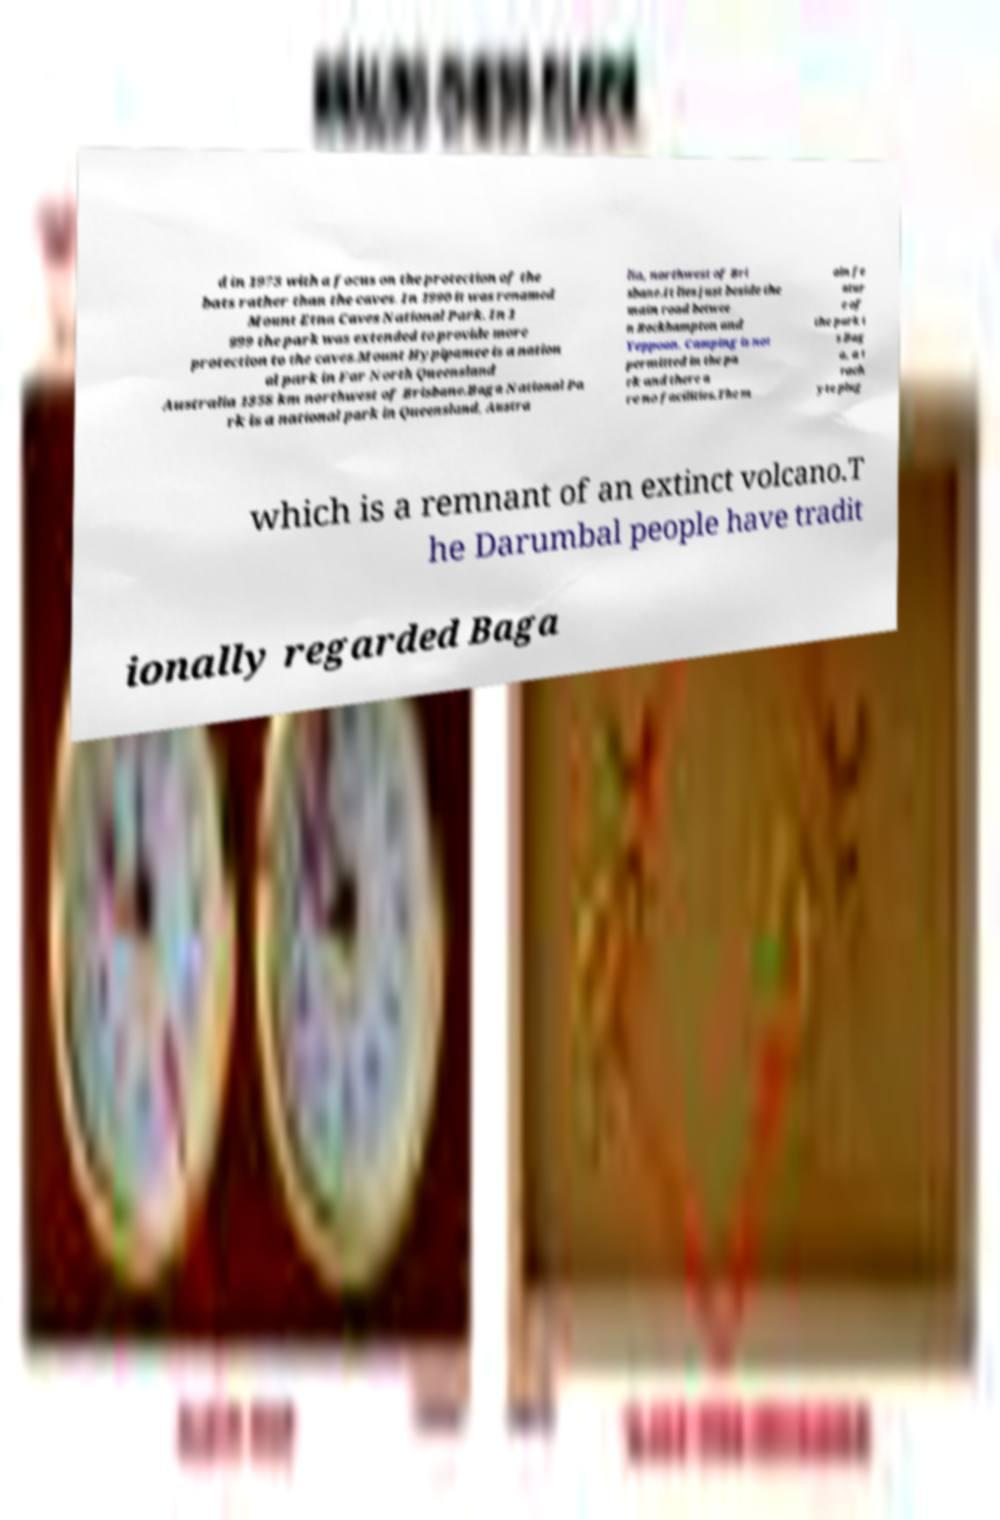Please read and relay the text visible in this image. What does it say? d in 1973 with a focus on the protection of the bats rather than the caves. In 1990 it was renamed Mount Etna Caves National Park. In 1 999 the park was extended to provide more protection to the caves.Mount Hypipamee is a nation al park in Far North Queensland Australia 1358 km northwest of Brisbane.Baga National Pa rk is a national park in Queensland, Austra lia, northwest of Bri sbane.It lies just beside the main road betwee n Rockhampton and Yeppoon. Camping is not permitted in the pa rk and there a re no facilities.The m ain fe atur e of the park i s Bag a, a t rach yte plug which is a remnant of an extinct volcano.T he Darumbal people have tradit ionally regarded Baga 